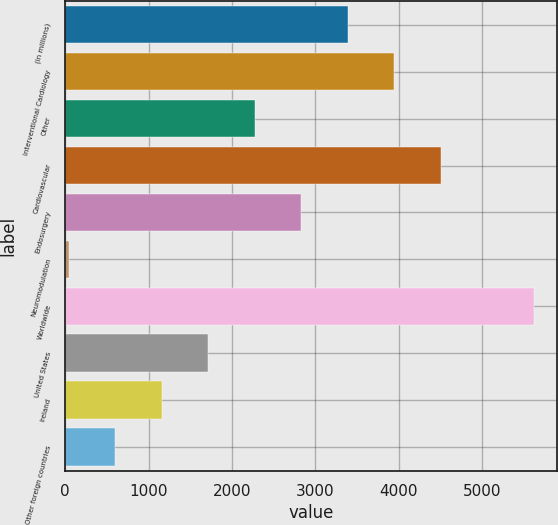Convert chart. <chart><loc_0><loc_0><loc_500><loc_500><bar_chart><fcel>(in millions)<fcel>Interventional Cardiology<fcel>Other<fcel>Cardiovascular<fcel>Endosurgery<fcel>Neuromodulation<fcel>Worldwide<fcel>United States<fcel>Ireland<fcel>Other foreign countries<nl><fcel>3392.8<fcel>3950.6<fcel>2277.2<fcel>4508.4<fcel>2835<fcel>46<fcel>5624<fcel>1719.4<fcel>1161.6<fcel>603.8<nl></chart> 